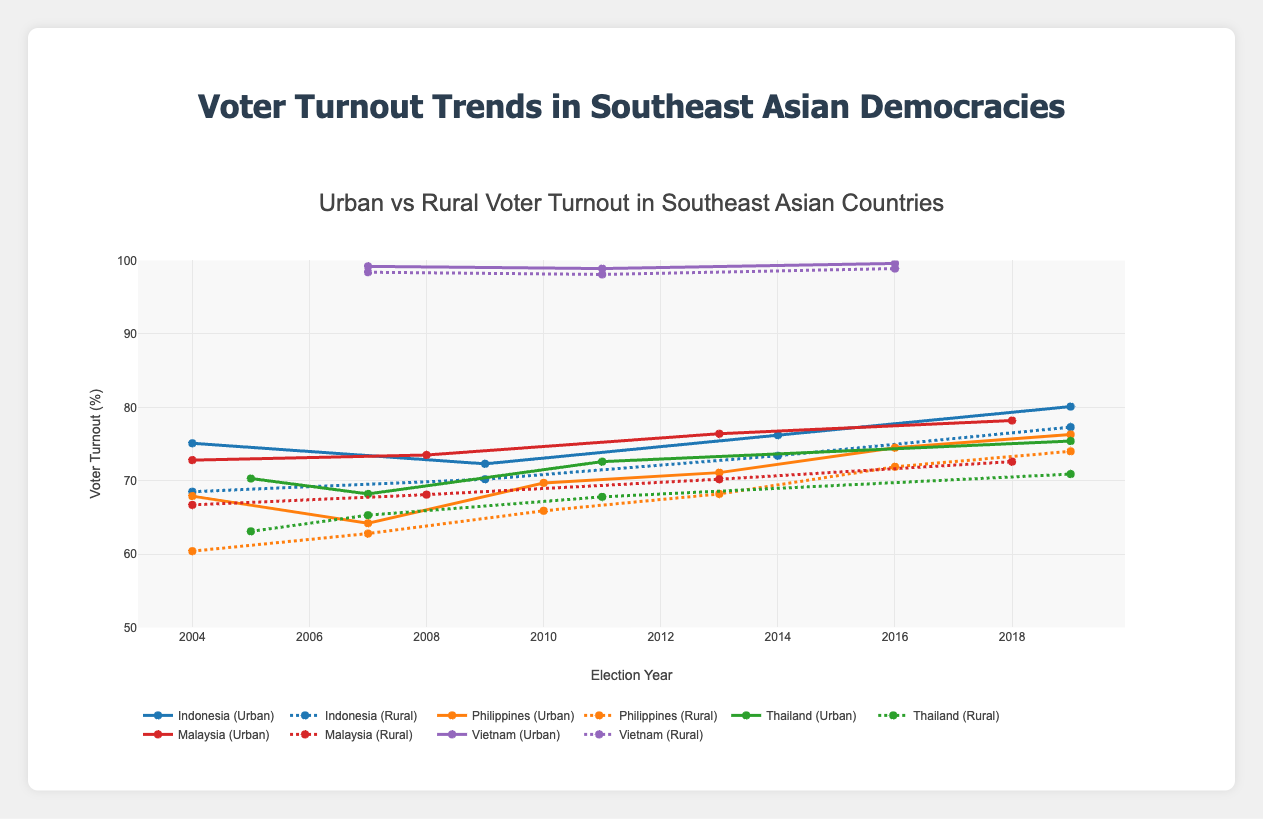Which country shows the highest overall urban voter turnout? Looking at the plot, each country's urban voter turnout values are represented by lines. The highest line among urban areas consistently over the years belongs to Vietnam, which almost reaches 100%
Answer: Vietnam How does the trend of rural voter turnout in Indonesia compare to urban voter turnout from 2004 to 2019? To compare the trends, observe the slope and values of both the urban and rural lines for Indonesia. Both trends increase over the years with urban voter turnout starting higher and peaking at 80.1% in 2019, while rural starts lower and peaks at 77.3%
Answer: Both trends increase, urban always higher In which country is the gap between urban and rural voter turnout the smallest in the most recent election year? Compare the difference between urban and rural voter turnout for each country in their most recent election year. For Vietnam in 2016, the difference is very small, signaling the smallest gap
Answer: Vietnam What's the average voter turnout in urban areas for the Philippines across all election years provided? Sum the urban voter turnout values for the Philippines and divide by the number of election years (67.9 + 64.2 + 69.7 + 71.1 + 74.5 + 76.3) / 6
Answer: 70.62 Which country shows the greatest increase in rural voter turnout from the first to the final election year? Calculate the increase for rural voter turnout from the first to the last election year for each country and find the largest increase: Indonesia (77.3 - 68.5 = 8.8), Philippines (74.0 - 60.4 = 13.6), Thailand (70.9 - 63.1 = 7.8), Malaysia (72.6 - 66.7 = 5.9), and Vietnam (98.9 - 98.4 = 0.5)
Answer: Philippines In which election year does Malaysia show the highest voter turnout for urban areas? By looking at the peak points of the Malaysia urban voter turnout line, 2018 shows the highest at 78.2%
Answer: 2018 Consider Indonesia's rural voter turnout trend. Is it consistently improving, declining, or fluctuating over the years? Follow the Indonesia rural voter turnout points from 2004 to 2019: 68.5%, 70.2%, 73.4%, 77.3%. It's consistently improving
Answer: Improving How does the urban voter turnout in Thailand in 2019 compare to Malaysia's in 2018? Refer to the plot points for both countries: Thailand's urban turnout in 2019 is 75.4%, while Malaysia's in 2018 is 78.2%
Answer: Malaysia's higher 